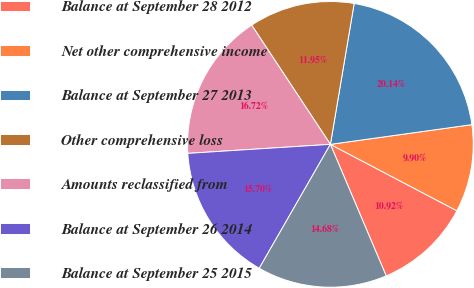<chart> <loc_0><loc_0><loc_500><loc_500><pie_chart><fcel>Balance at September 28 2012<fcel>Net other comprehensive income<fcel>Balance at September 27 2013<fcel>Other comprehensive loss<fcel>Amounts reclassified from<fcel>Balance at September 26 2014<fcel>Balance at September 25 2015<nl><fcel>10.92%<fcel>9.9%<fcel>20.14%<fcel>11.95%<fcel>16.72%<fcel>15.7%<fcel>14.68%<nl></chart> 